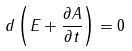Convert formula to latex. <formula><loc_0><loc_0><loc_500><loc_500>d \left ( E + \frac { \partial A } { \partial t } \right ) = 0</formula> 